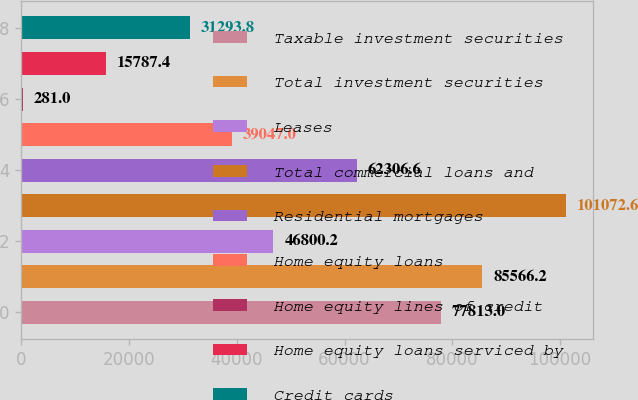Convert chart to OTSL. <chart><loc_0><loc_0><loc_500><loc_500><bar_chart><fcel>Taxable investment securities<fcel>Total investment securities<fcel>Leases<fcel>Total commercial loans and<fcel>Residential mortgages<fcel>Home equity loans<fcel>Home equity lines of credit<fcel>Home equity loans serviced by<fcel>Credit cards<nl><fcel>77813<fcel>85566.2<fcel>46800.2<fcel>101073<fcel>62306.6<fcel>39047<fcel>281<fcel>15787.4<fcel>31293.8<nl></chart> 